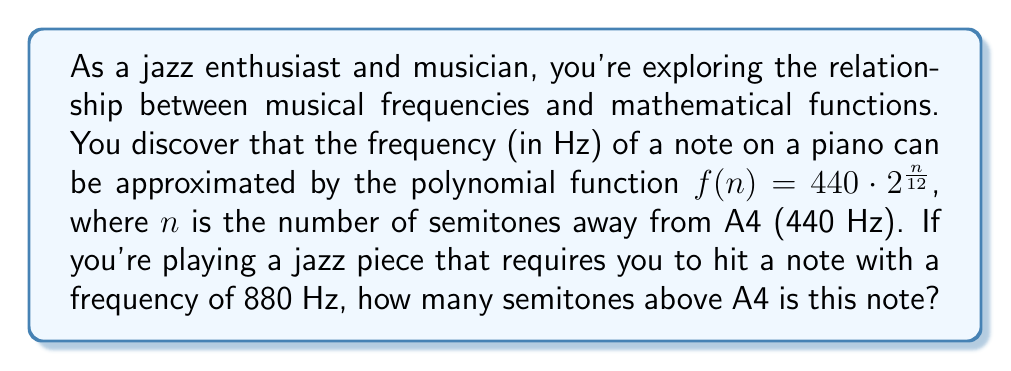Solve this math problem. Let's approach this step-by-step:

1) We're given the function $f(n) = 440 \cdot 2^{\frac{n}{12}}$, where:
   - $f(n)$ is the frequency in Hz
   - $n$ is the number of semitones away from A4
   - 440 Hz is the frequency of A4

2) We need to find $n$ when $f(n) = 880$ Hz. So, let's set up the equation:

   $$880 = 440 \cdot 2^{\frac{n}{12}}$$

3) Simplify the right side:

   $$880 = 440 \cdot 2^{\frac{n}{12}}$$
   $$2 = 2^{\frac{n}{12}}$$

4) Now, we can solve for $n$ using logarithms. Let's apply $\log_2$ to both sides:

   $$\log_2(2) = \log_2(2^{\frac{n}{12}})$$

5) Using the logarithm property $\log_a(a^x) = x$, we get:

   $$1 = \frac{n}{12}$$

6) Multiply both sides by 12:

   $$12 = n$$

Therefore, the note with a frequency of 880 Hz is 12 semitones above A4.
Answer: 12 semitones 